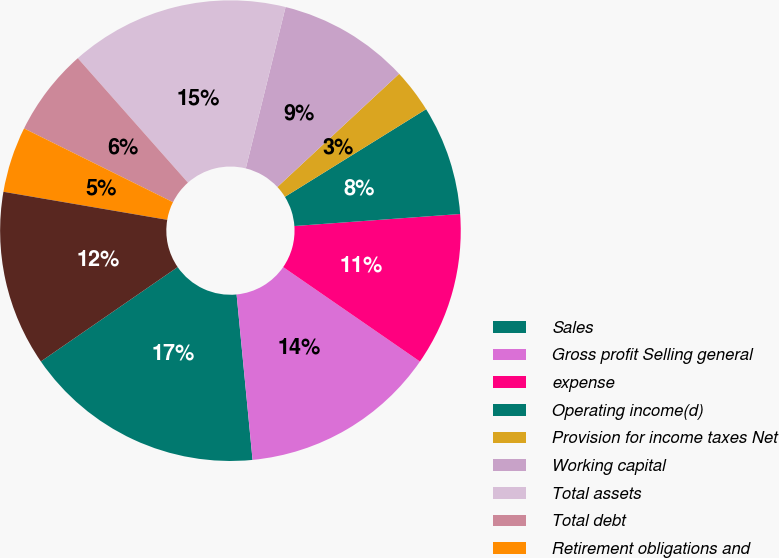<chart> <loc_0><loc_0><loc_500><loc_500><pie_chart><fcel>Sales<fcel>Gross profit Selling general<fcel>expense<fcel>Operating income(d)<fcel>Provision for income taxes Net<fcel>Working capital<fcel>Total assets<fcel>Total debt<fcel>Retirement obligations and<fcel>Total equity<nl><fcel>16.92%<fcel>13.85%<fcel>10.77%<fcel>7.69%<fcel>3.08%<fcel>9.23%<fcel>15.38%<fcel>6.15%<fcel>4.62%<fcel>12.31%<nl></chart> 